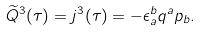<formula> <loc_0><loc_0><loc_500><loc_500>\widetilde { Q } ^ { 3 } ( \tau ) = j ^ { 3 } ( \tau ) = - \epsilon _ { a } ^ { b } q ^ { a } p _ { b } .</formula> 